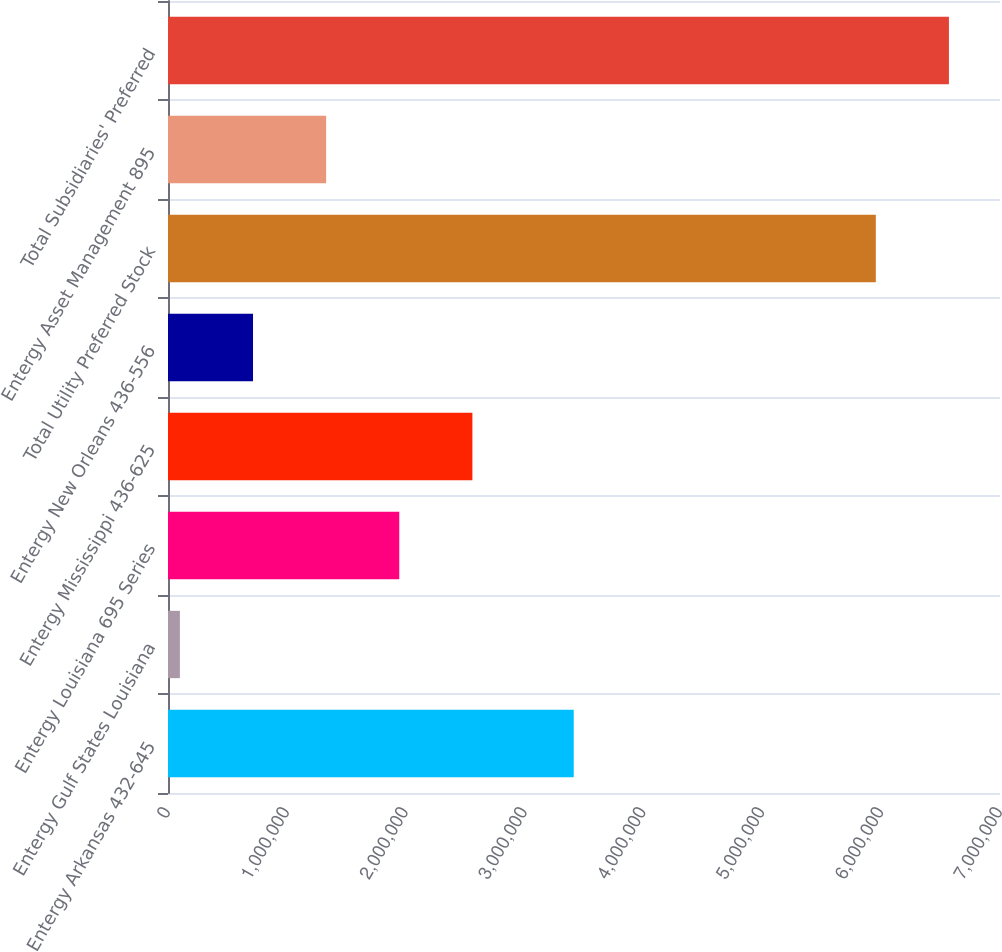Convert chart to OTSL. <chart><loc_0><loc_0><loc_500><loc_500><bar_chart><fcel>Entergy Arkansas 432-645<fcel>Entergy Gulf States Louisiana<fcel>Entergy Louisiana 695 Series<fcel>Entergy Mississippi 436-625<fcel>Entergy New Orleans 436-556<fcel>Total Utility Preferred Stock<fcel>Entergy Asset Management 895<fcel>Total Subsidiaries' Preferred<nl><fcel>3.4135e+06<fcel>100000<fcel>1.94574e+06<fcel>2.56099e+06<fcel>715248<fcel>5.9551e+06<fcel>1.3305e+06<fcel>6.57035e+06<nl></chart> 